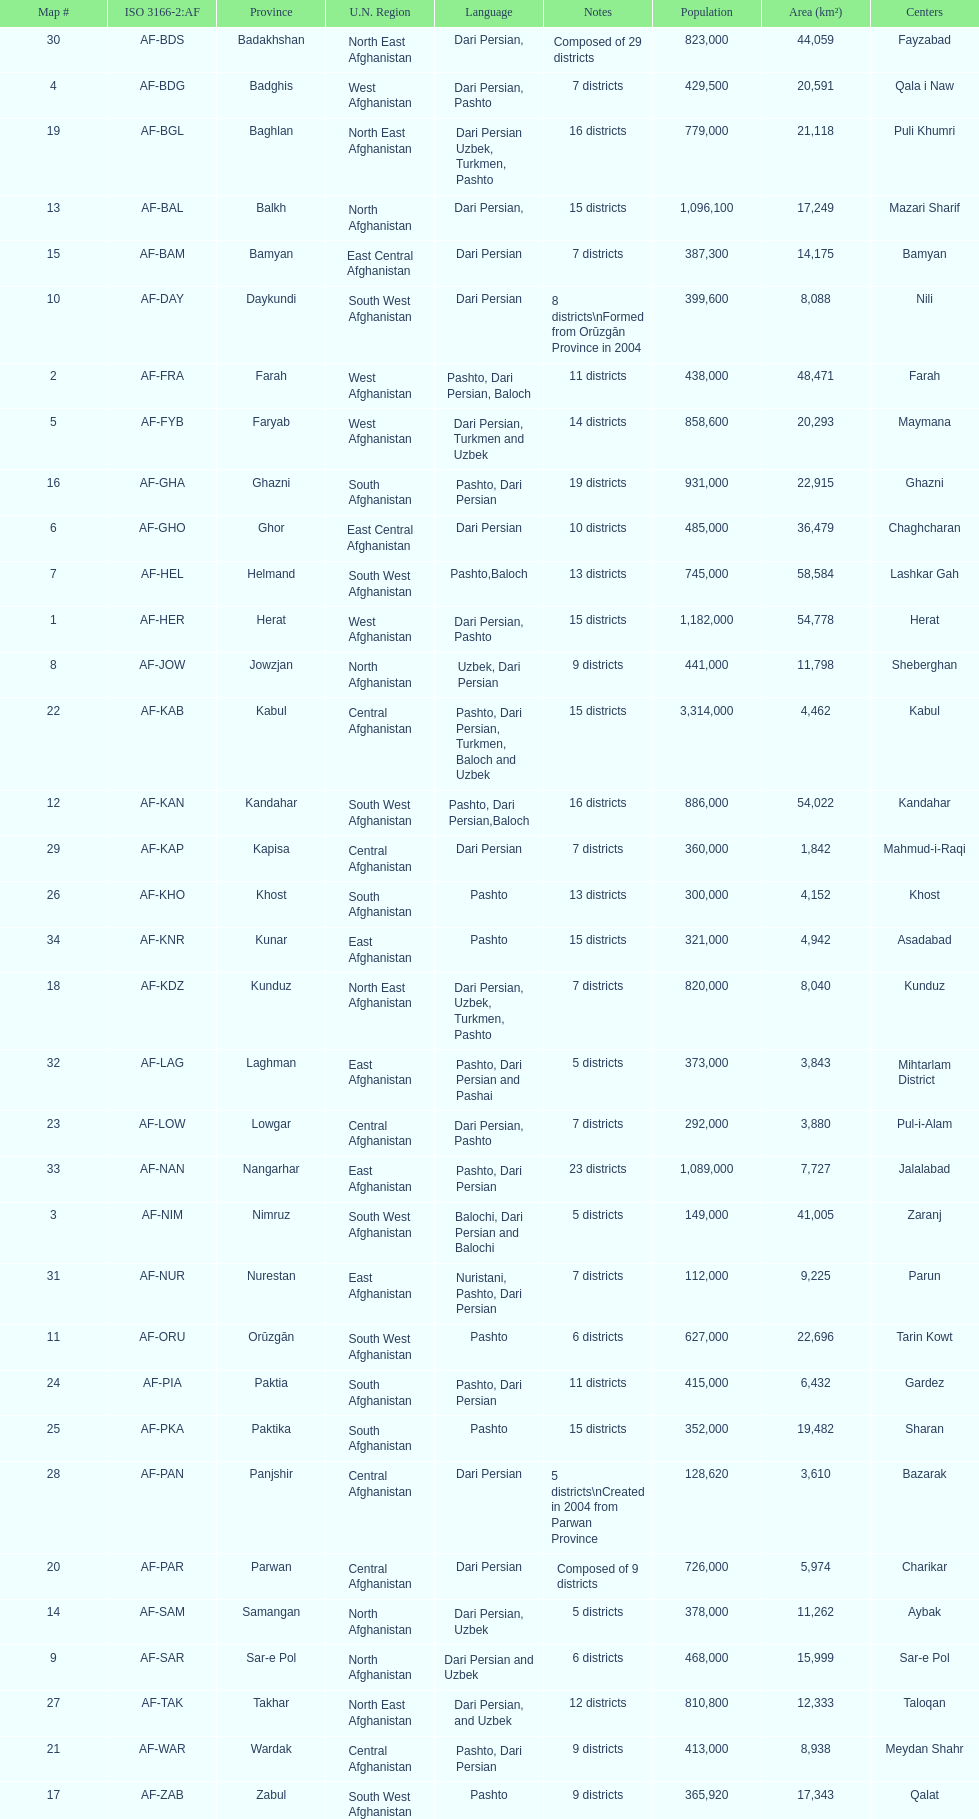Which province has the most districts? Badakhshan. 